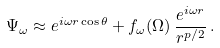Convert formula to latex. <formula><loc_0><loc_0><loc_500><loc_500>\Psi _ { \omega } \approx e ^ { i \omega r \cos \theta } + f _ { \omega } ( \Omega ) \, \frac { e ^ { i \omega r } } { r ^ { p / 2 } } \, .</formula> 